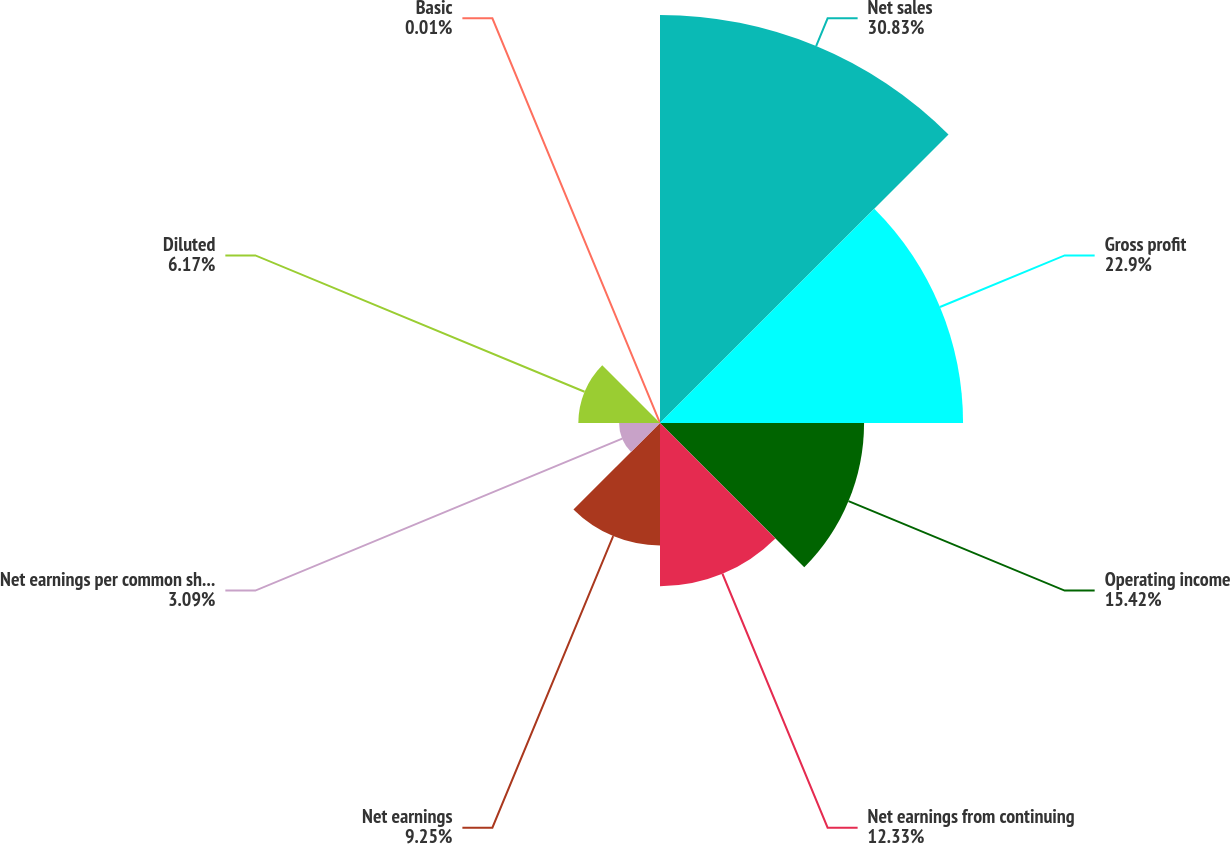<chart> <loc_0><loc_0><loc_500><loc_500><pie_chart><fcel>Net sales<fcel>Gross profit<fcel>Operating income<fcel>Net earnings from continuing<fcel>Net earnings<fcel>Net earnings per common share<fcel>Diluted<fcel>Basic<nl><fcel>30.83%<fcel>22.9%<fcel>15.42%<fcel>12.33%<fcel>9.25%<fcel>3.09%<fcel>6.17%<fcel>0.01%<nl></chart> 